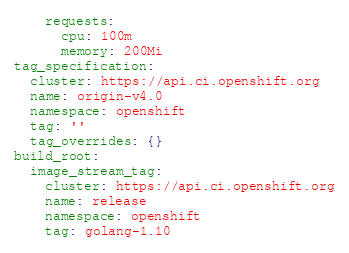Convert code to text. <code><loc_0><loc_0><loc_500><loc_500><_YAML_>    requests:
      cpu: 100m
      memory: 200Mi
tag_specification:
  cluster: https://api.ci.openshift.org
  name: origin-v4.0
  namespace: openshift
  tag: ''
  tag_overrides: {}
build_root:
  image_stream_tag:
    cluster: https://api.ci.openshift.org
    name: release
    namespace: openshift
    tag: golang-1.10
</code> 